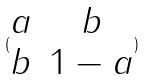<formula> <loc_0><loc_0><loc_500><loc_500>( \begin{matrix} a & b \\ b & 1 - a \end{matrix} )</formula> 